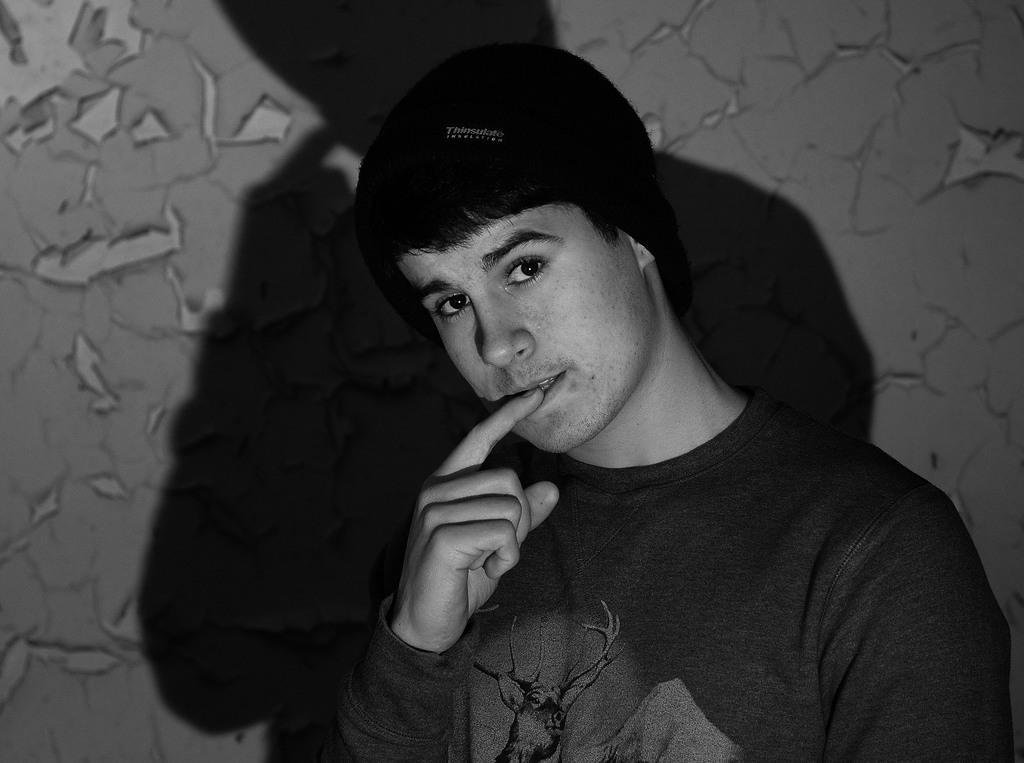How would you summarize this image in a sentence or two? Black and white picture. This man is looking forward. On the wall there is a shadow of this person.  